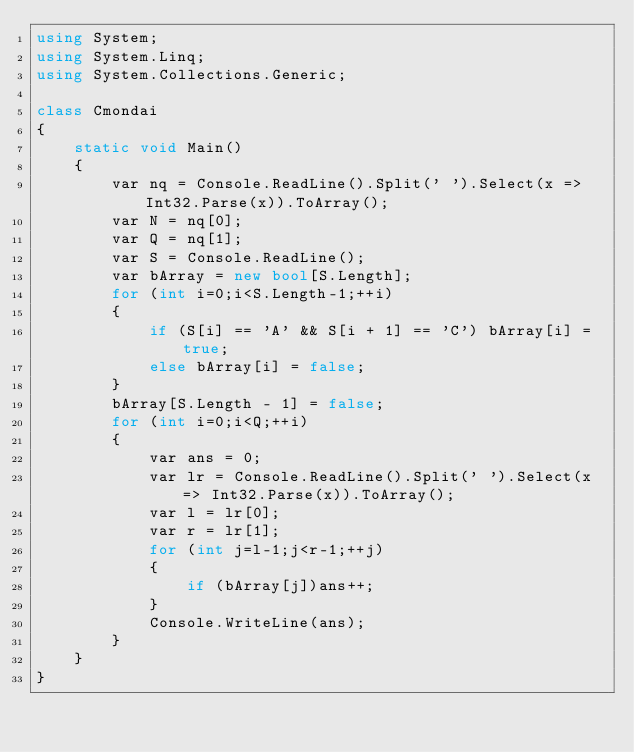Convert code to text. <code><loc_0><loc_0><loc_500><loc_500><_C#_>using System;
using System.Linq;
using System.Collections.Generic;

class Cmondai
{
    static void Main()
    {
        var nq = Console.ReadLine().Split(' ').Select(x => Int32.Parse(x)).ToArray();
        var N = nq[0];
        var Q = nq[1];
        var S = Console.ReadLine();
        var bArray = new bool[S.Length];
        for (int i=0;i<S.Length-1;++i)
        {
            if (S[i] == 'A' && S[i + 1] == 'C') bArray[i] = true;
            else bArray[i] = false;
        }
        bArray[S.Length - 1] = false;
        for (int i=0;i<Q;++i)
        {
            var ans = 0;
            var lr = Console.ReadLine().Split(' ').Select(x => Int32.Parse(x)).ToArray();
            var l = lr[0];
            var r = lr[1];
            for (int j=l-1;j<r-1;++j)
            {
                if (bArray[j])ans++;
            }
            Console.WriteLine(ans);
        }
    }
}</code> 